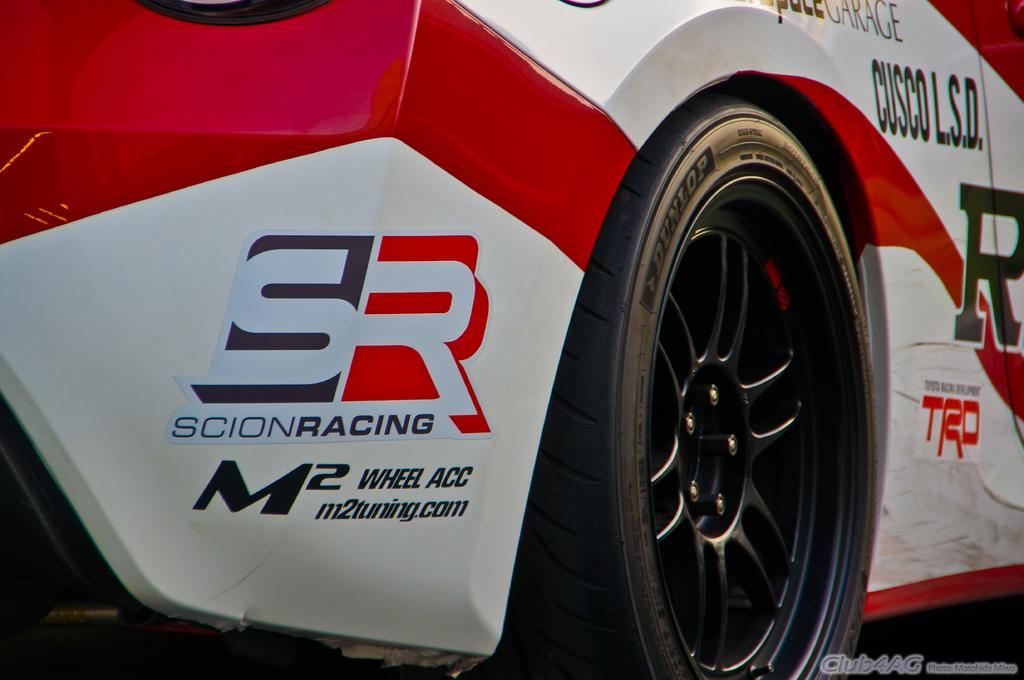What is the main subject of the image? The main subject of the image is a car. Can you describe any specific features of the car? Yes, the tire of the car is black in color. What type of advice is the car giving to the pet in the image? There is no pet present in the image, and the car is an inanimate object, so it cannot give advice. 